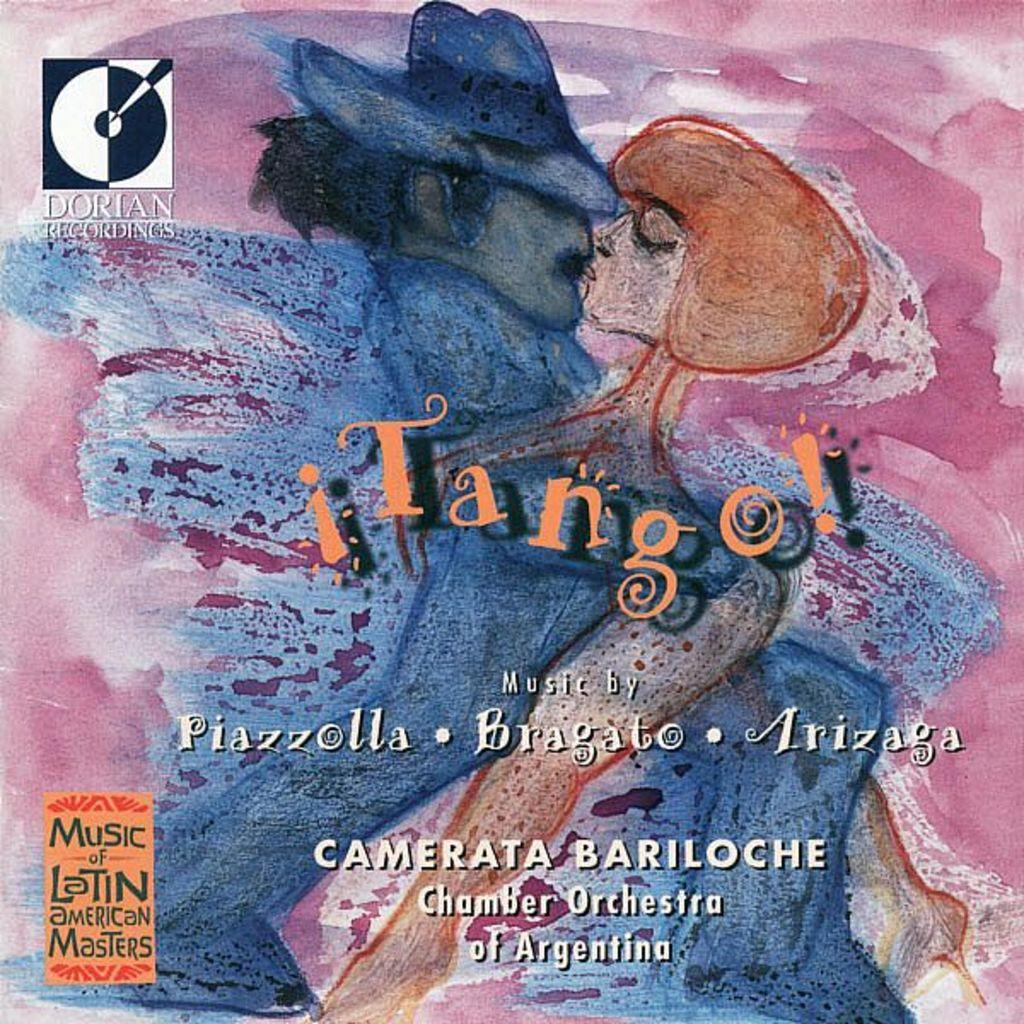<image>
Write a terse but informative summary of the picture. The title of chamber orchestra music is Tango . 